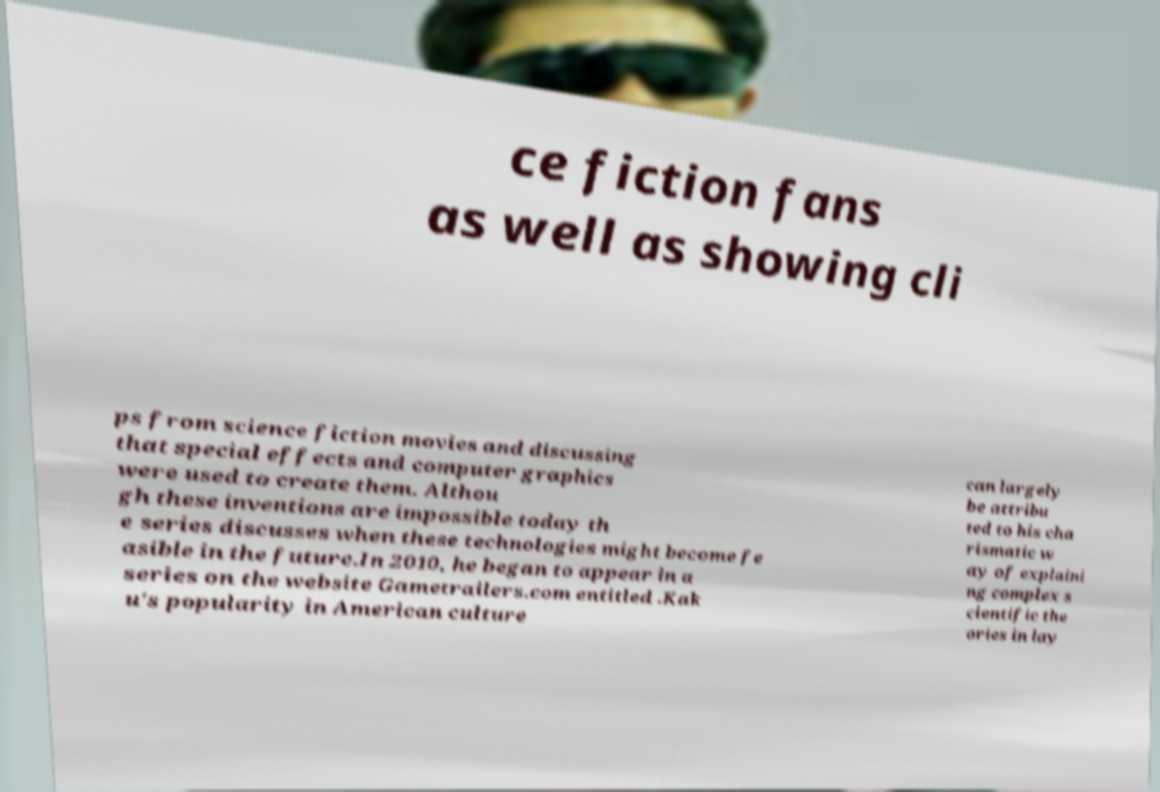Could you extract and type out the text from this image? ce fiction fans as well as showing cli ps from science fiction movies and discussing that special effects and computer graphics were used to create them. Althou gh these inventions are impossible today th e series discusses when these technologies might become fe asible in the future.In 2010, he began to appear in a series on the website Gametrailers.com entitled .Kak u's popularity in American culture can largely be attribu ted to his cha rismatic w ay of explaini ng complex s cientific the ories in lay 